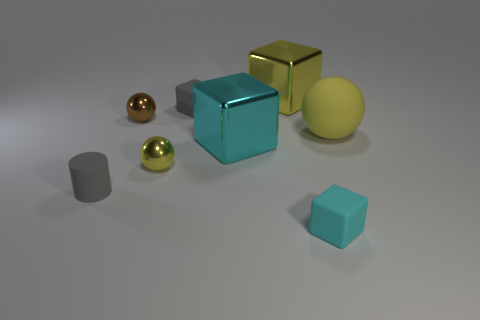How many other things are the same shape as the brown thing?
Your response must be concise. 2. Does the cyan metal cube have the same size as the yellow sphere to the right of the small cyan rubber cube?
Provide a short and direct response. Yes. How many objects are either shiny objects in front of the big yellow shiny thing or big metallic blocks?
Make the answer very short. 4. The small shiny object that is behind the big cyan metal block has what shape?
Your response must be concise. Sphere. Are there the same number of large cyan blocks that are right of the big cyan cube and tiny matte things behind the large yellow rubber object?
Provide a succinct answer. No. There is a rubber object that is to the left of the large yellow shiny block and behind the cylinder; what color is it?
Give a very brief answer. Gray. What is the material of the tiny sphere on the right side of the tiny metallic object behind the cyan metallic cube?
Provide a short and direct response. Metal. Is the gray cylinder the same size as the cyan rubber cube?
Give a very brief answer. Yes. What number of tiny objects are metallic cubes or cylinders?
Ensure brevity in your answer.  1. How many cubes are in front of the yellow metallic sphere?
Your answer should be compact. 1. 